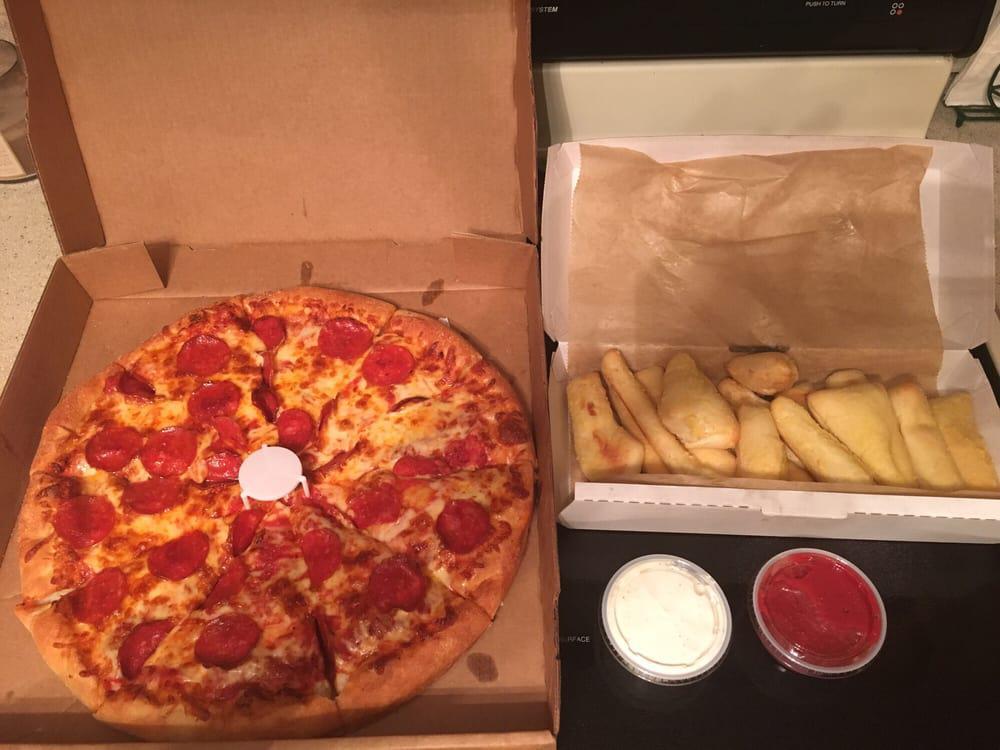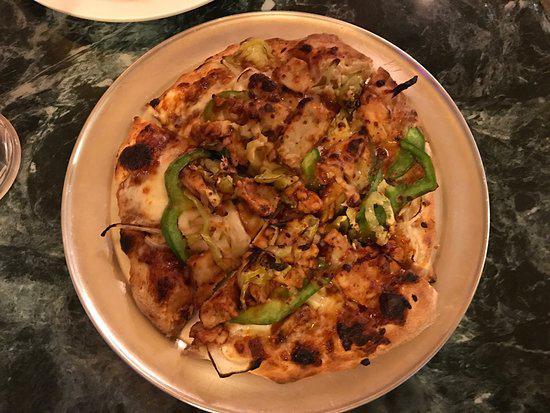The first image is the image on the left, the second image is the image on the right. Evaluate the accuracy of this statement regarding the images: "There are two complete pizzas.". Is it true? Answer yes or no. Yes. The first image is the image on the left, the second image is the image on the right. Evaluate the accuracy of this statement regarding the images: "One image shows a pizza in an open box and includes at least two condiment containers in the image.". Is it true? Answer yes or no. Yes. 